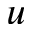Convert formula to latex. <formula><loc_0><loc_0><loc_500><loc_500>u</formula> 